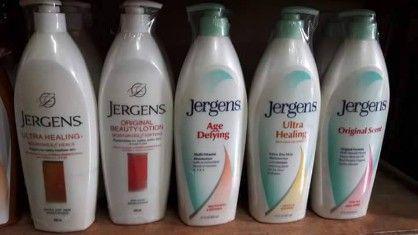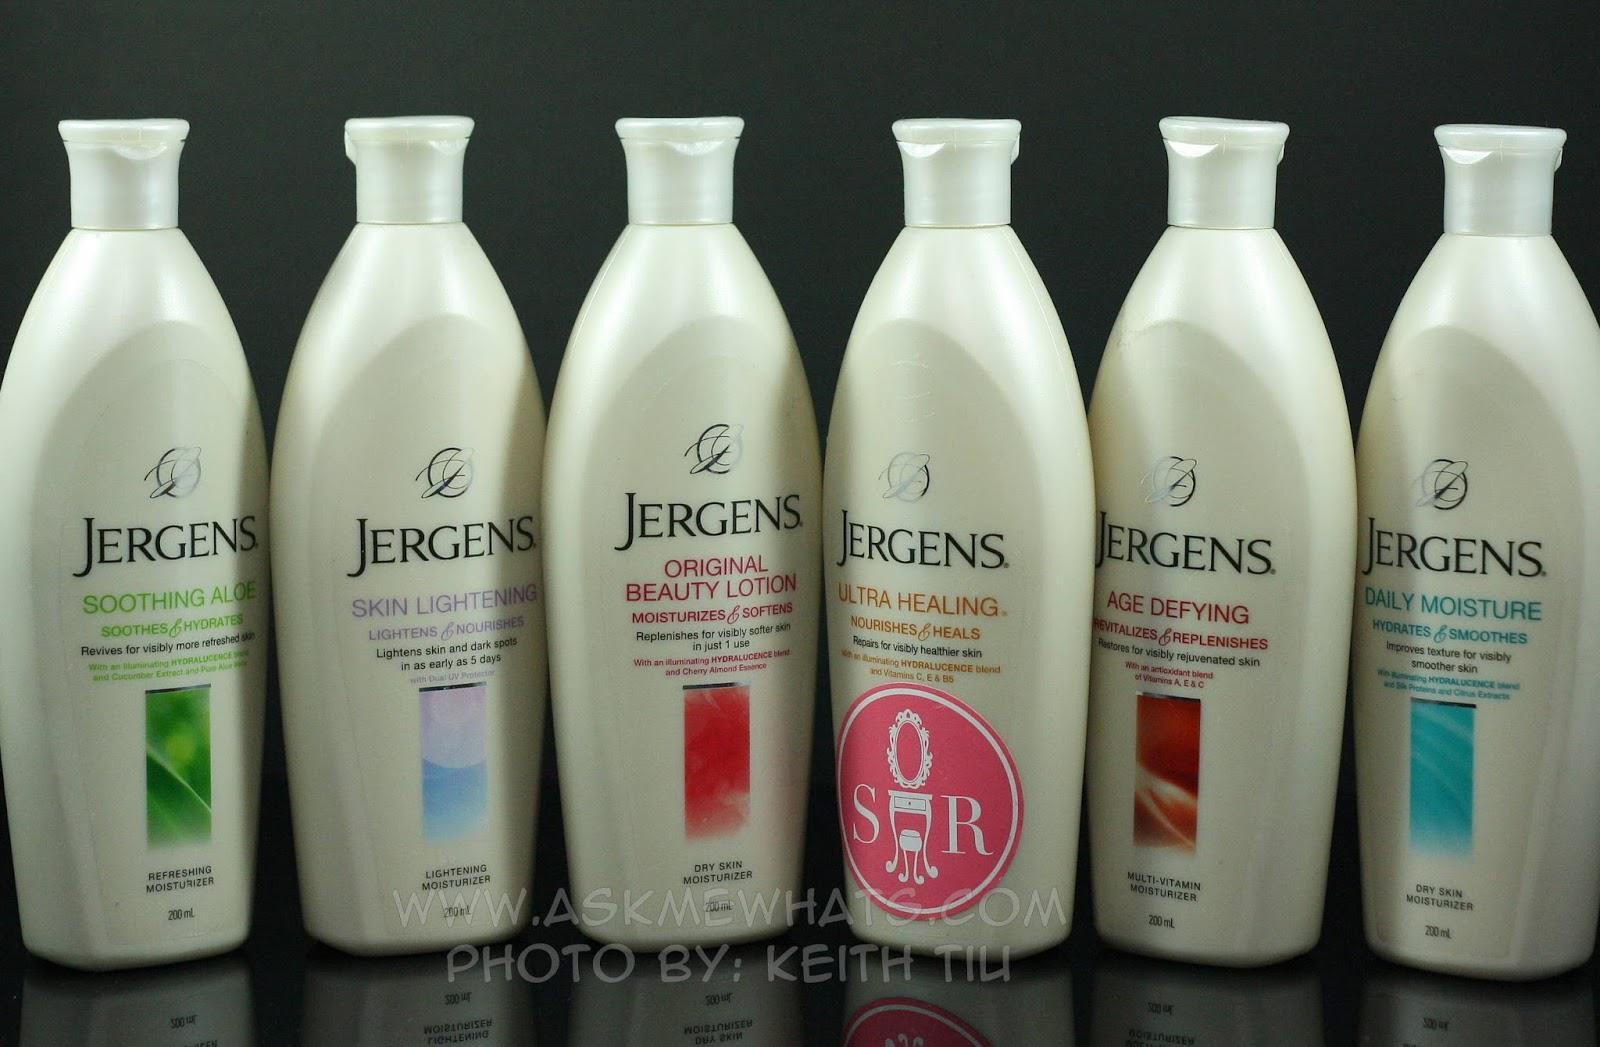The first image is the image on the left, the second image is the image on the right. Assess this claim about the two images: "No more than three lotion bottles are visible in the left image.". Correct or not? Answer yes or no. No. 